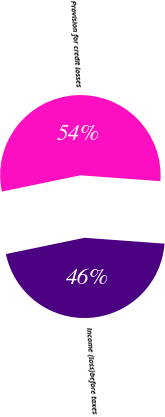Convert chart. <chart><loc_0><loc_0><loc_500><loc_500><pie_chart><fcel>Provision for credit losses<fcel>Income (loss)before taxes<nl><fcel>54.42%<fcel>45.58%<nl></chart> 